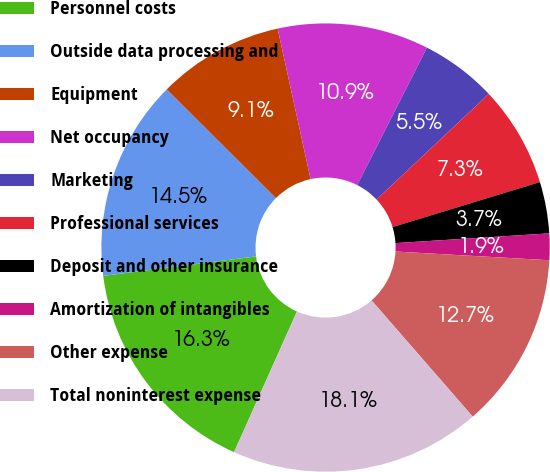Convert chart. <chart><loc_0><loc_0><loc_500><loc_500><pie_chart><fcel>Personnel costs<fcel>Outside data processing and<fcel>Equipment<fcel>Net occupancy<fcel>Marketing<fcel>Professional services<fcel>Deposit and other insurance<fcel>Amortization of intangibles<fcel>Other expense<fcel>Total noninterest expense<nl><fcel>16.29%<fcel>14.49%<fcel>9.1%<fcel>10.9%<fcel>5.51%<fcel>7.3%<fcel>3.71%<fcel>1.91%<fcel>12.7%<fcel>18.09%<nl></chart> 